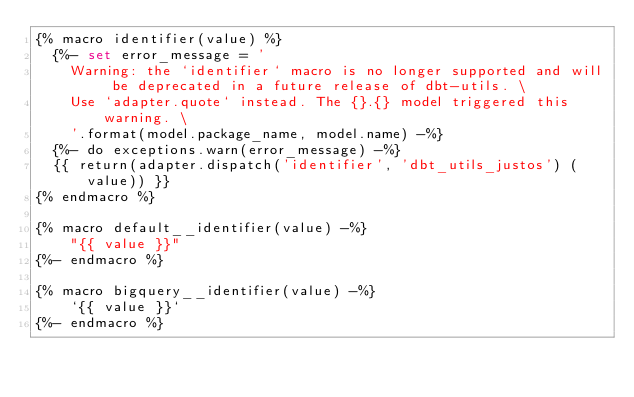Convert code to text. <code><loc_0><loc_0><loc_500><loc_500><_SQL_>{% macro identifier(value) %}	
  {%- set error_message = '
    Warning: the `identifier` macro is no longer supported and will be deprecated in a future release of dbt-utils. \
    Use `adapter.quote` instead. The {}.{} model triggered this warning. \
    '.format(model.package_name, model.name) -%}
  {%- do exceptions.warn(error_message) -%}
  {{ return(adapter.dispatch('identifier', 'dbt_utils_justos') (value)) }}
{% endmacro %}	

{% macro default__identifier(value) -%}	
    "{{ value }}"	
{%- endmacro %}	

{% macro bigquery__identifier(value) -%}	
    `{{ value }}`	
{%- endmacro %}
</code> 